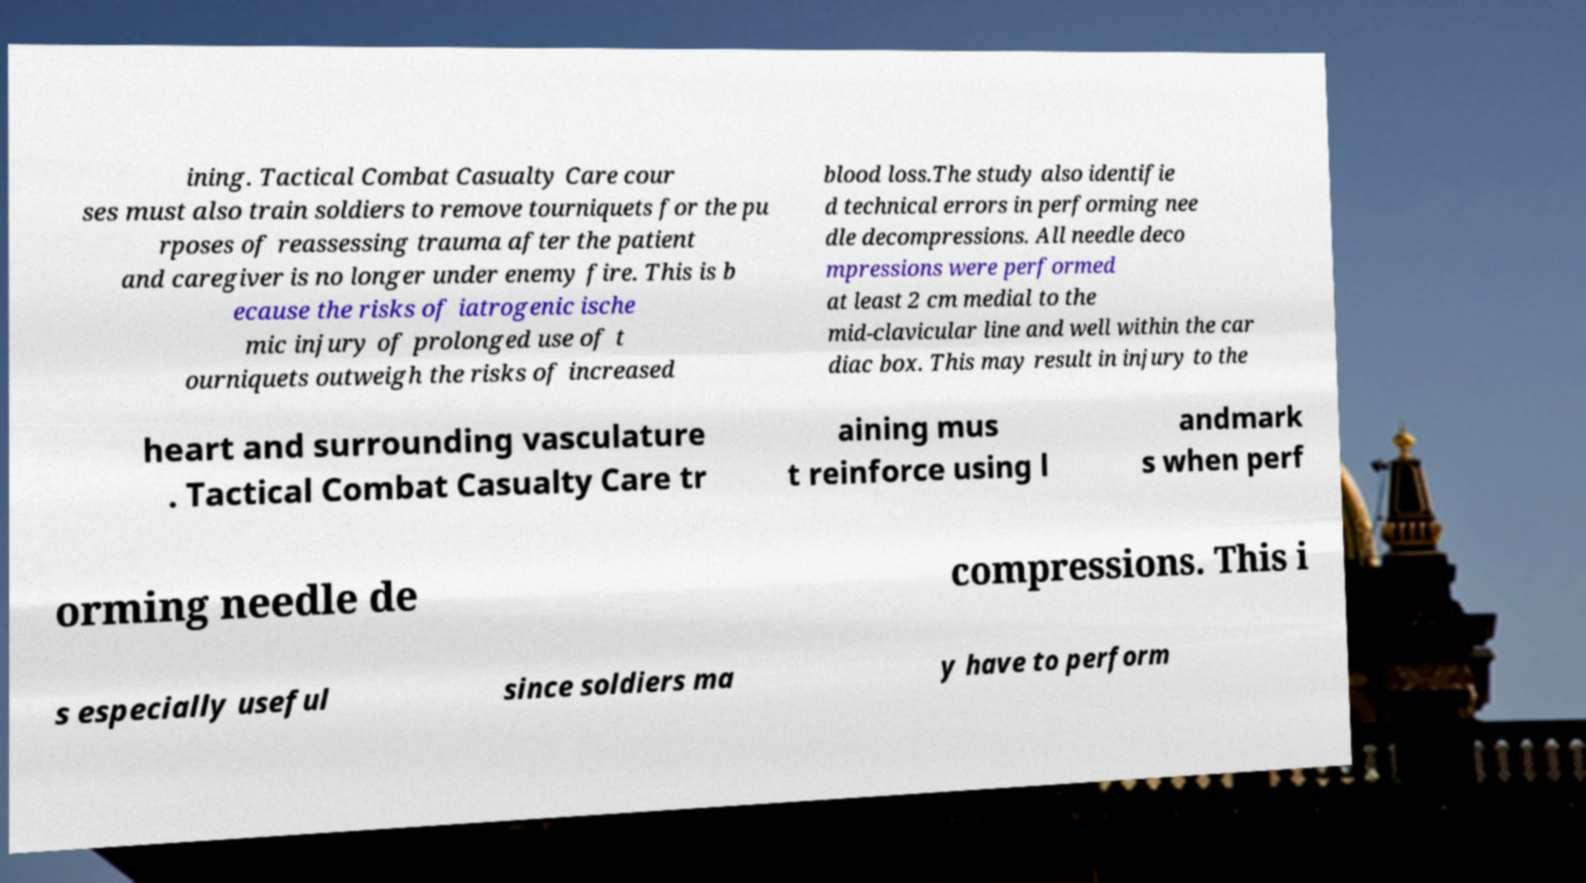Can you accurately transcribe the text from the provided image for me? ining. Tactical Combat Casualty Care cour ses must also train soldiers to remove tourniquets for the pu rposes of reassessing trauma after the patient and caregiver is no longer under enemy fire. This is b ecause the risks of iatrogenic ische mic injury of prolonged use of t ourniquets outweigh the risks of increased blood loss.The study also identifie d technical errors in performing nee dle decompressions. All needle deco mpressions were performed at least 2 cm medial to the mid-clavicular line and well within the car diac box. This may result in injury to the heart and surrounding vasculature . Tactical Combat Casualty Care tr aining mus t reinforce using l andmark s when perf orming needle de compressions. This i s especially useful since soldiers ma y have to perform 